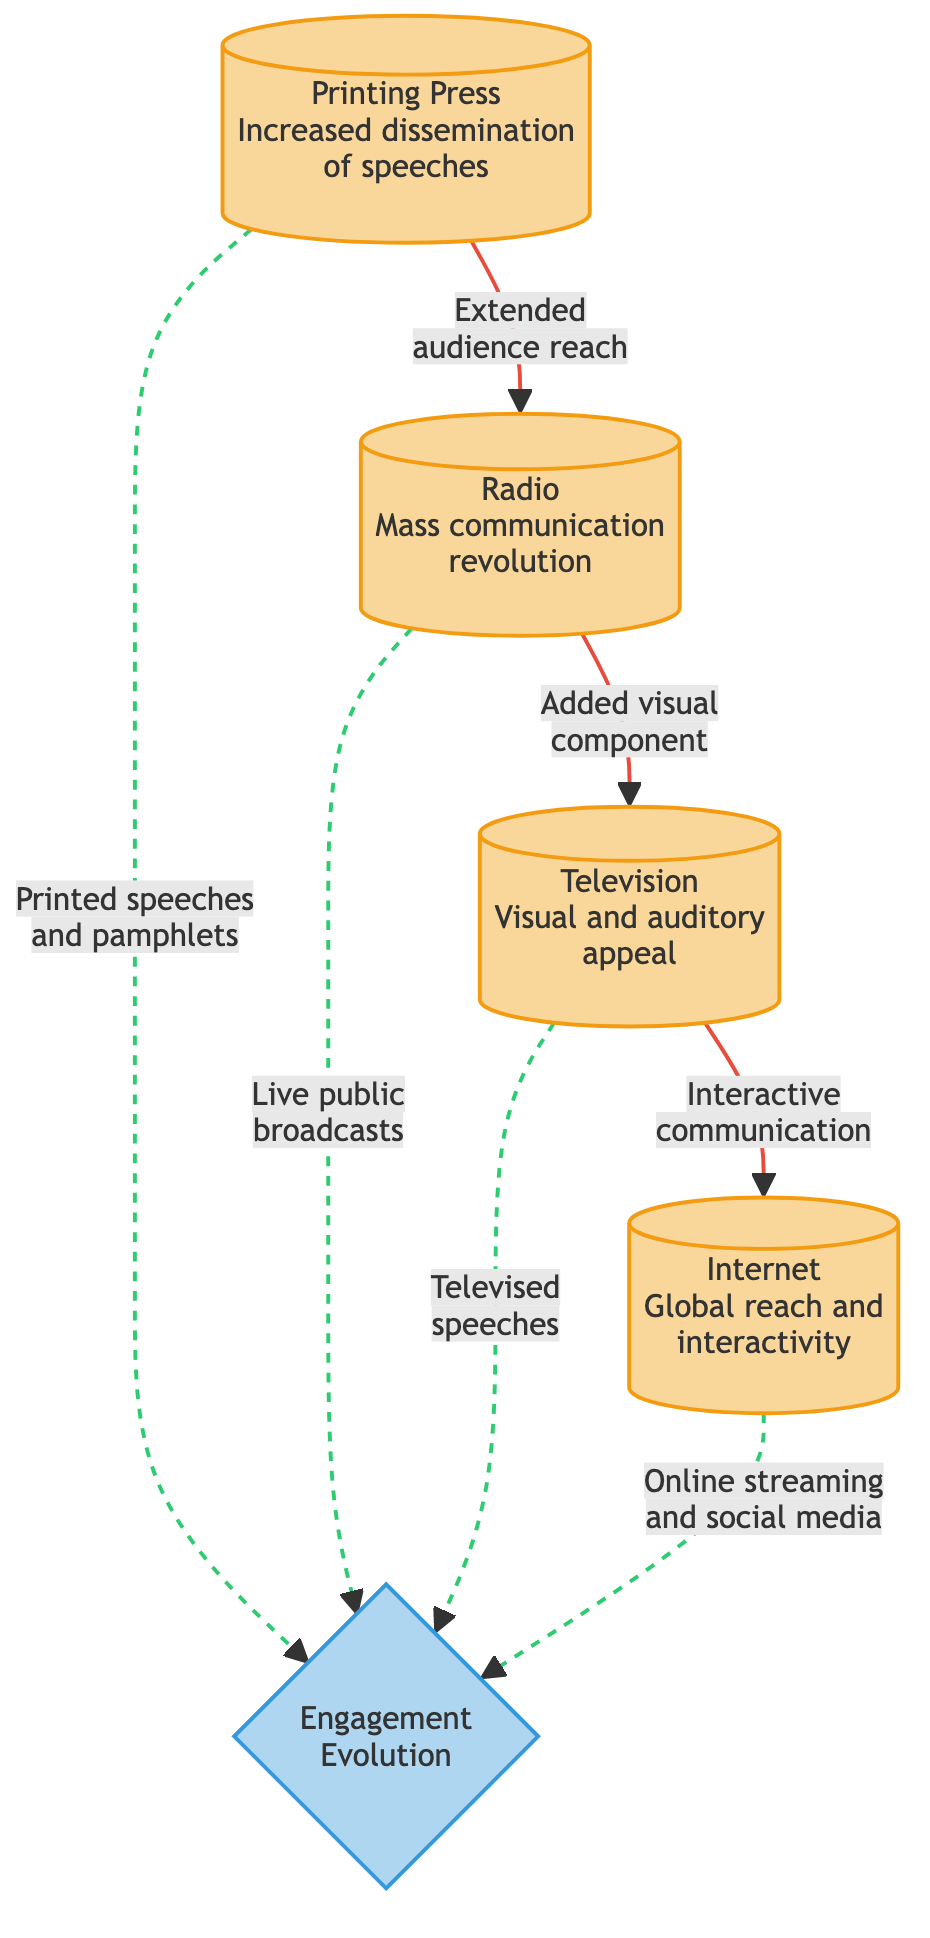What are the four technological advancements listed in the diagram? The diagram outlines four technologies that transformed public speaking: the Printing Press, Radio, Television, and Internet. These are clearly labeled as separate nodes in the flowchart.
Answer: Printing Press, Radio, Television, Internet How many main nodes are there in the diagram? There are a total of five main nodes in the flowchart: four representing technological advancements and one representing engagement evolution. This can be determined by counting the distinct nodes displayed.
Answer: 5 Which technological advancement is associated with "Visual and auditory appeal"? The node labeled "Television" is specifically indicated as having "Visual and auditory appeal." This can be identified by looking at the description linked to the Television node.
Answer: Television What does the relationship between Radio and Television imply about the evolution of engagement? The relationship suggests that the addition of a visual component in Television enhanced audience engagement compared to Radio. This can be determined by analyzing the link from Radio to Television that indicates an evolution in engagement strategies.
Answer: Added visual component Which advancement is linked to "Live public broadcasts"? The diagram shows that "Live public broadcasts" relates to the Radio technology. This relationship is represented by the dashed line connecting Radio to the engagement evolution node.
Answer: Radio Which technological advance led to "Online streaming and social media"? The node indicating "Online streaming and social media" is connected to the Internet advancement. This link is clear in the diagram as it directly flows from the Internet node.
Answer: Internet How do the printed speeches contribute to engagement evolution in the diagram? The flowchart illustrates that printed speeches and pamphlets from the Printing Press are shown to have a non-direct influence on engagement evolution, represented by a dashed line leading to the engagement node.
Answer: Printed speeches and pamphlets What will be the next step of audience engagement evolution after the introduction of the Internet? While not laid out in the diagram, the indication is that the Internet fosters further evolution in audience engagement due to its global reach and interactivity, connecting to a broader potential for engagement methods.
Answer: Global reach and interactivity How does the flow of the diagram connect the technological advancements to audience engagement? The flow of the diagram shows arrows indicating that each technological advancement logically progresses to the next, ultimately leading to the evolution of audience engagement, emphasizing a transformation in how audiences interact with speeches over time.
Answer: Engagement Evolution 